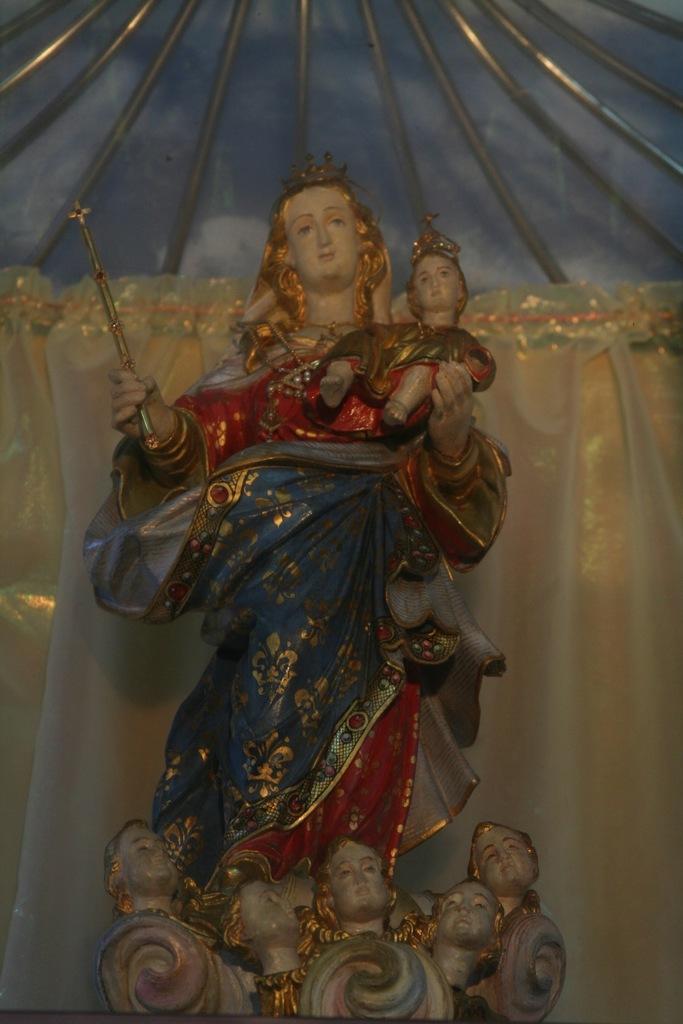Could you give a brief overview of what you see in this image? This picture consist of idols and having a colorful clothes and at the top I can see rods. 